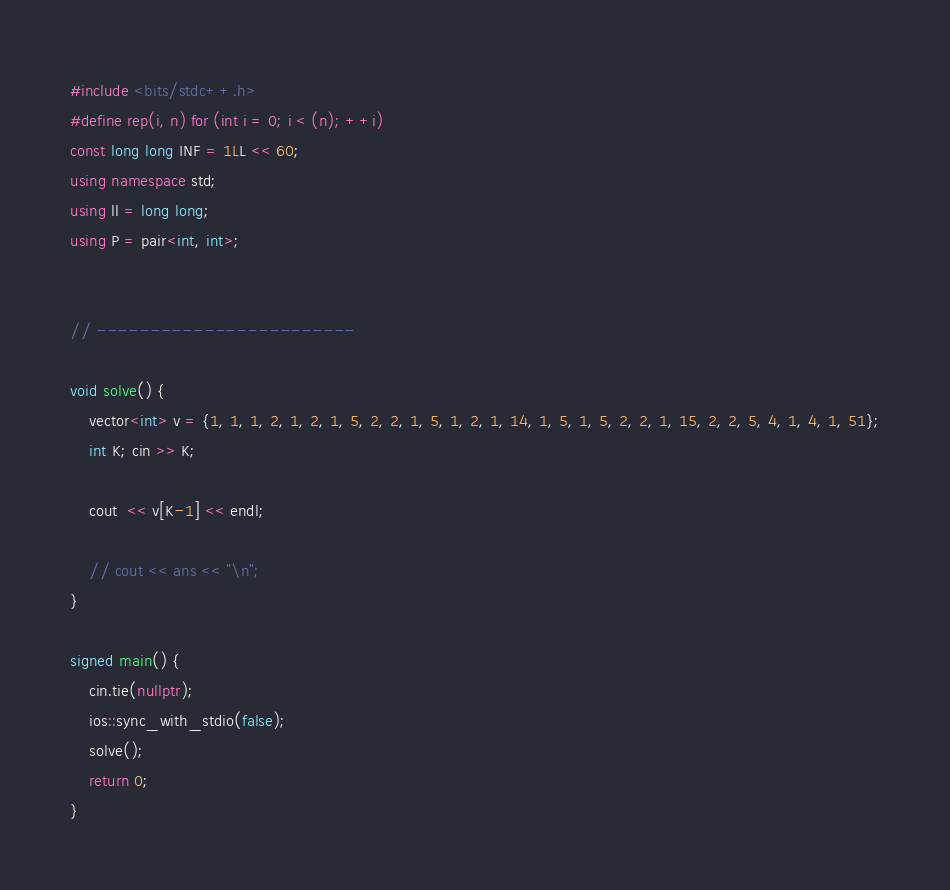Convert code to text. <code><loc_0><loc_0><loc_500><loc_500><_C++_>#include <bits/stdc++.h>
#define rep(i, n) for (int i = 0; i < (n); ++i)
const long long INF = 1LL << 60;
using namespace std;
using ll = long long;
using P = pair<int, int>;


// ------------------------

void solve() {
    vector<int> v = {1, 1, 1, 2, 1, 2, 1, 5, 2, 2, 1, 5, 1, 2, 1, 14, 1, 5, 1, 5, 2, 2, 1, 15, 2, 2, 5, 4, 1, 4, 1, 51};
    int K; cin >> K;

    cout  << v[K-1] << endl;

    // cout << ans << "\n";
}

signed main() {
    cin.tie(nullptr);
    ios::sync_with_stdio(false);
    solve();
    return 0;
}</code> 